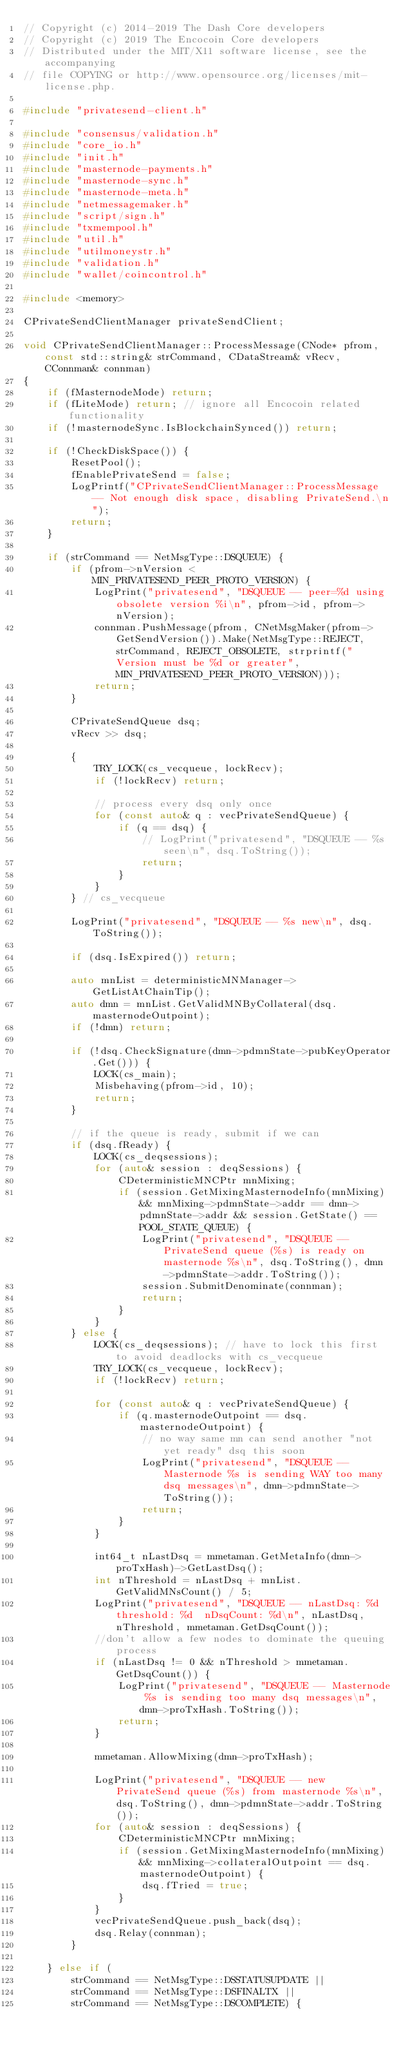<code> <loc_0><loc_0><loc_500><loc_500><_C++_>// Copyright (c) 2014-2019 The Dash Core developers
// Copyright (c) 2019 The Encocoin Core developers
// Distributed under the MIT/X11 software license, see the accompanying
// file COPYING or http://www.opensource.org/licenses/mit-license.php.

#include "privatesend-client.h"

#include "consensus/validation.h"
#include "core_io.h"
#include "init.h"
#include "masternode-payments.h"
#include "masternode-sync.h"
#include "masternode-meta.h"
#include "netmessagemaker.h"
#include "script/sign.h"
#include "txmempool.h"
#include "util.h"
#include "utilmoneystr.h"
#include "validation.h"
#include "wallet/coincontrol.h"

#include <memory>

CPrivateSendClientManager privateSendClient;

void CPrivateSendClientManager::ProcessMessage(CNode* pfrom, const std::string& strCommand, CDataStream& vRecv, CConnman& connman)
{
    if (fMasternodeMode) return;
    if (fLiteMode) return; // ignore all Encocoin related functionality
    if (!masternodeSync.IsBlockchainSynced()) return;

    if (!CheckDiskSpace()) {
        ResetPool();
        fEnablePrivateSend = false;
        LogPrintf("CPrivateSendClientManager::ProcessMessage -- Not enough disk space, disabling PrivateSend.\n");
        return;
    }

    if (strCommand == NetMsgType::DSQUEUE) {
        if (pfrom->nVersion < MIN_PRIVATESEND_PEER_PROTO_VERSION) {
            LogPrint("privatesend", "DSQUEUE -- peer=%d using obsolete version %i\n", pfrom->id, pfrom->nVersion);
            connman.PushMessage(pfrom, CNetMsgMaker(pfrom->GetSendVersion()).Make(NetMsgType::REJECT, strCommand, REJECT_OBSOLETE, strprintf("Version must be %d or greater", MIN_PRIVATESEND_PEER_PROTO_VERSION)));
            return;
        }

        CPrivateSendQueue dsq;
        vRecv >> dsq;

        {
            TRY_LOCK(cs_vecqueue, lockRecv);
            if (!lockRecv) return;

            // process every dsq only once
            for (const auto& q : vecPrivateSendQueue) {
                if (q == dsq) {
                    // LogPrint("privatesend", "DSQUEUE -- %s seen\n", dsq.ToString());
                    return;
                }
            }
        } // cs_vecqueue

        LogPrint("privatesend", "DSQUEUE -- %s new\n", dsq.ToString());

        if (dsq.IsExpired()) return;

        auto mnList = deterministicMNManager->GetListAtChainTip();
        auto dmn = mnList.GetValidMNByCollateral(dsq.masternodeOutpoint);
        if (!dmn) return;

        if (!dsq.CheckSignature(dmn->pdmnState->pubKeyOperator.Get())) {
            LOCK(cs_main);
            Misbehaving(pfrom->id, 10);
            return;
        }

        // if the queue is ready, submit if we can
        if (dsq.fReady) {
            LOCK(cs_deqsessions);
            for (auto& session : deqSessions) {
                CDeterministicMNCPtr mnMixing;
                if (session.GetMixingMasternodeInfo(mnMixing) && mnMixing->pdmnState->addr == dmn->pdmnState->addr && session.GetState() == POOL_STATE_QUEUE) {
                    LogPrint("privatesend", "DSQUEUE -- PrivateSend queue (%s) is ready on masternode %s\n", dsq.ToString(), dmn->pdmnState->addr.ToString());
                    session.SubmitDenominate(connman);
                    return;
                }
            }
        } else {
            LOCK(cs_deqsessions); // have to lock this first to avoid deadlocks with cs_vecqueue
            TRY_LOCK(cs_vecqueue, lockRecv);
            if (!lockRecv) return;

            for (const auto& q : vecPrivateSendQueue) {
                if (q.masternodeOutpoint == dsq.masternodeOutpoint) {
                    // no way same mn can send another "not yet ready" dsq this soon
                    LogPrint("privatesend", "DSQUEUE -- Masternode %s is sending WAY too many dsq messages\n", dmn->pdmnState->ToString());
                    return;
                }
            }

            int64_t nLastDsq = mmetaman.GetMetaInfo(dmn->proTxHash)->GetLastDsq();
            int nThreshold = nLastDsq + mnList.GetValidMNsCount() / 5;
            LogPrint("privatesend", "DSQUEUE -- nLastDsq: %d  threshold: %d  nDsqCount: %d\n", nLastDsq, nThreshold, mmetaman.GetDsqCount());
            //don't allow a few nodes to dominate the queuing process
            if (nLastDsq != 0 && nThreshold > mmetaman.GetDsqCount()) {
                LogPrint("privatesend", "DSQUEUE -- Masternode %s is sending too many dsq messages\n", dmn->proTxHash.ToString());
                return;
            }

            mmetaman.AllowMixing(dmn->proTxHash);

            LogPrint("privatesend", "DSQUEUE -- new PrivateSend queue (%s) from masternode %s\n", dsq.ToString(), dmn->pdmnState->addr.ToString());
            for (auto& session : deqSessions) {
                CDeterministicMNCPtr mnMixing;
                if (session.GetMixingMasternodeInfo(mnMixing) && mnMixing->collateralOutpoint == dsq.masternodeOutpoint) {
                    dsq.fTried = true;
                }
            }
            vecPrivateSendQueue.push_back(dsq);
            dsq.Relay(connman);
        }

    } else if (
        strCommand == NetMsgType::DSSTATUSUPDATE ||
        strCommand == NetMsgType::DSFINALTX ||
        strCommand == NetMsgType::DSCOMPLETE) {</code> 